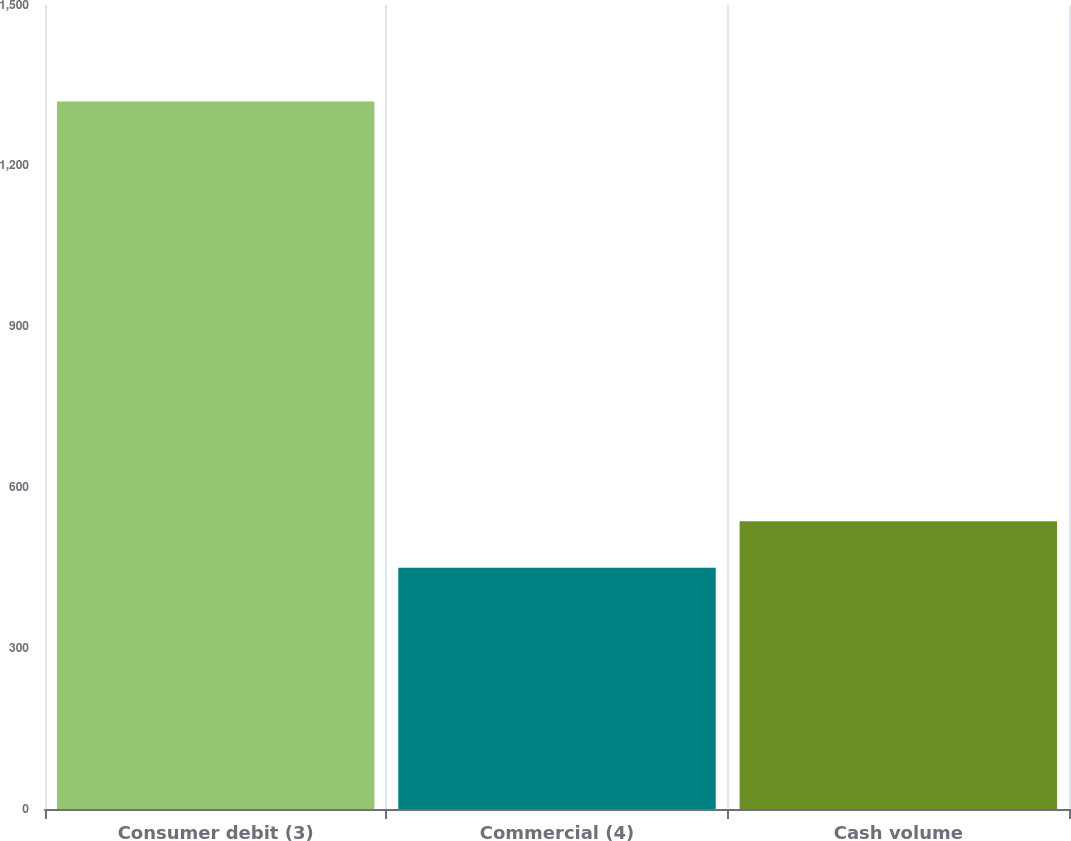<chart> <loc_0><loc_0><loc_500><loc_500><bar_chart><fcel>Consumer debit (3)<fcel>Commercial (4)<fcel>Cash volume<nl><fcel>1320<fcel>450<fcel>537<nl></chart> 